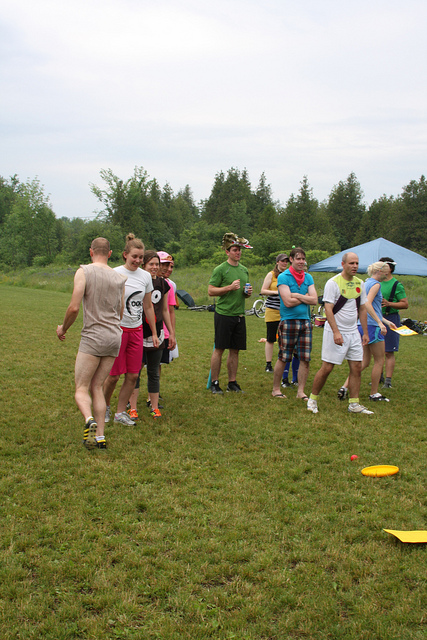If this image were the beginning of a movie, what would be the next scene? In the next scene, the group could be shown actively playing frisbee, with laughter and cheers filling the air as they pass the frisbee back and forth. The camera might then cut to different pairs or small groups within the event having conversations, revealing snippets of their lives and personalities. A subplot could begin to unfold, perhaps involving a budding romance, a mystery item one of them finds near the forest edge, or an unexpected visitor arriving at the scene. 